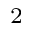Convert formula to latex. <formula><loc_0><loc_0><loc_500><loc_500>_ { 2 }</formula> 